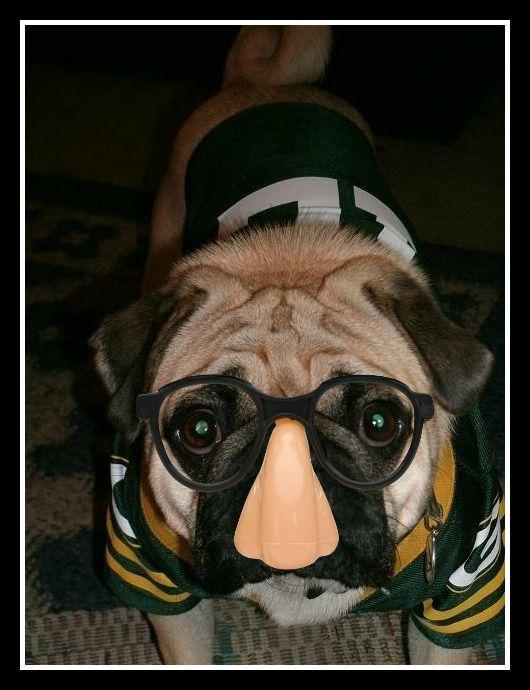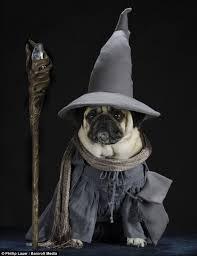The first image is the image on the left, the second image is the image on the right. Analyze the images presented: Is the assertion "One of the dogs shown is wearing a hat with a brim." valid? Answer yes or no. Yes. 